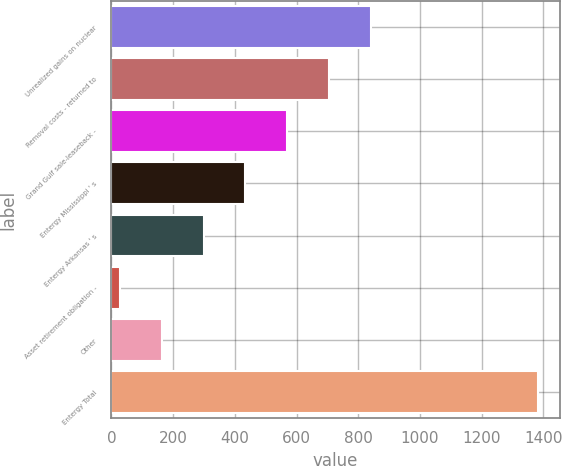Convert chart to OTSL. <chart><loc_0><loc_0><loc_500><loc_500><bar_chart><fcel>Unrealized gains on nuclear<fcel>Removal costs - returned to<fcel>Grand Gulf sale-leaseback -<fcel>Entergy Mississippi ' s<fcel>Entergy Arkansas ' s<fcel>Asset retirement obligation -<fcel>Other<fcel>Entergy Total<nl><fcel>841.24<fcel>705.65<fcel>570.06<fcel>434.47<fcel>298.88<fcel>27.7<fcel>163.29<fcel>1383.6<nl></chart> 